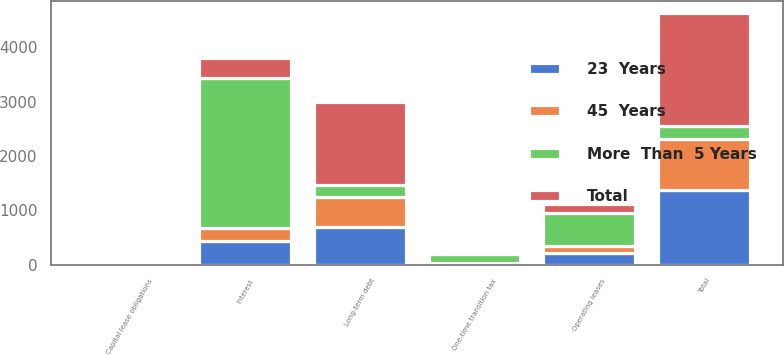Convert chart. <chart><loc_0><loc_0><loc_500><loc_500><stacked_bar_chart><ecel><fcel>One-time transition tax<fcel>Long-term debt<fcel>Capital lease obligations<fcel>Operating leases<fcel>Interest<fcel>Total<nl><fcel>More  Than  5 Years<fcel>160<fcel>226.5<fcel>5<fcel>617<fcel>2753<fcel>226.5<nl><fcel>45  Years<fcel>13<fcel>549<fcel>1<fcel>131<fcel>242<fcel>951<nl><fcel>23  Years<fcel>26<fcel>696<fcel>1<fcel>211<fcel>436<fcel>1370<nl><fcel>Total<fcel>26<fcel>1513<fcel>1<fcel>160<fcel>375<fcel>2075<nl></chart> 